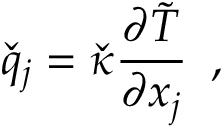<formula> <loc_0><loc_0><loc_500><loc_500>\check { q } _ { j } = \check { \kappa } \frac { \partial \tilde { T } } { \partial x _ { j } } \, ,</formula> 